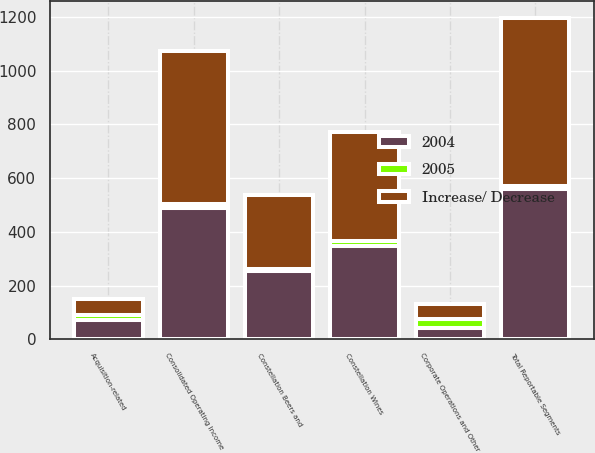<chart> <loc_0><loc_0><loc_500><loc_500><stacked_bar_chart><ecel><fcel>Constellation Wines<fcel>Constellation Beers and<fcel>Corporate Operations and Other<fcel>Total Reportable Segments<fcel>Acquisition-related<fcel>Consolidated Operating Income<nl><fcel>Increase/ Decrease<fcel>406.6<fcel>276.1<fcel>56<fcel>626.7<fcel>58.8<fcel>567.9<nl><fcel>2004<fcel>348.1<fcel>252.5<fcel>41.7<fcel>558.9<fcel>71.5<fcel>487.4<nl><fcel>2005<fcel>17<fcel>9<fcel>34<fcel>12<fcel>18<fcel>17<nl></chart> 